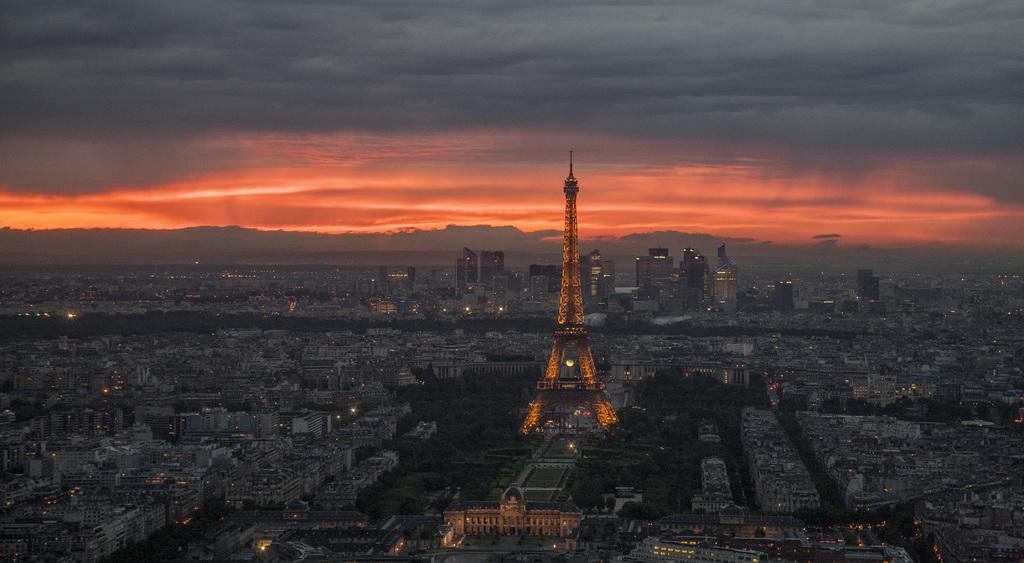Describe this image in one or two sentences. In this picture we can see an Eiffel tower. There are many buildings and a few lights in the background. 